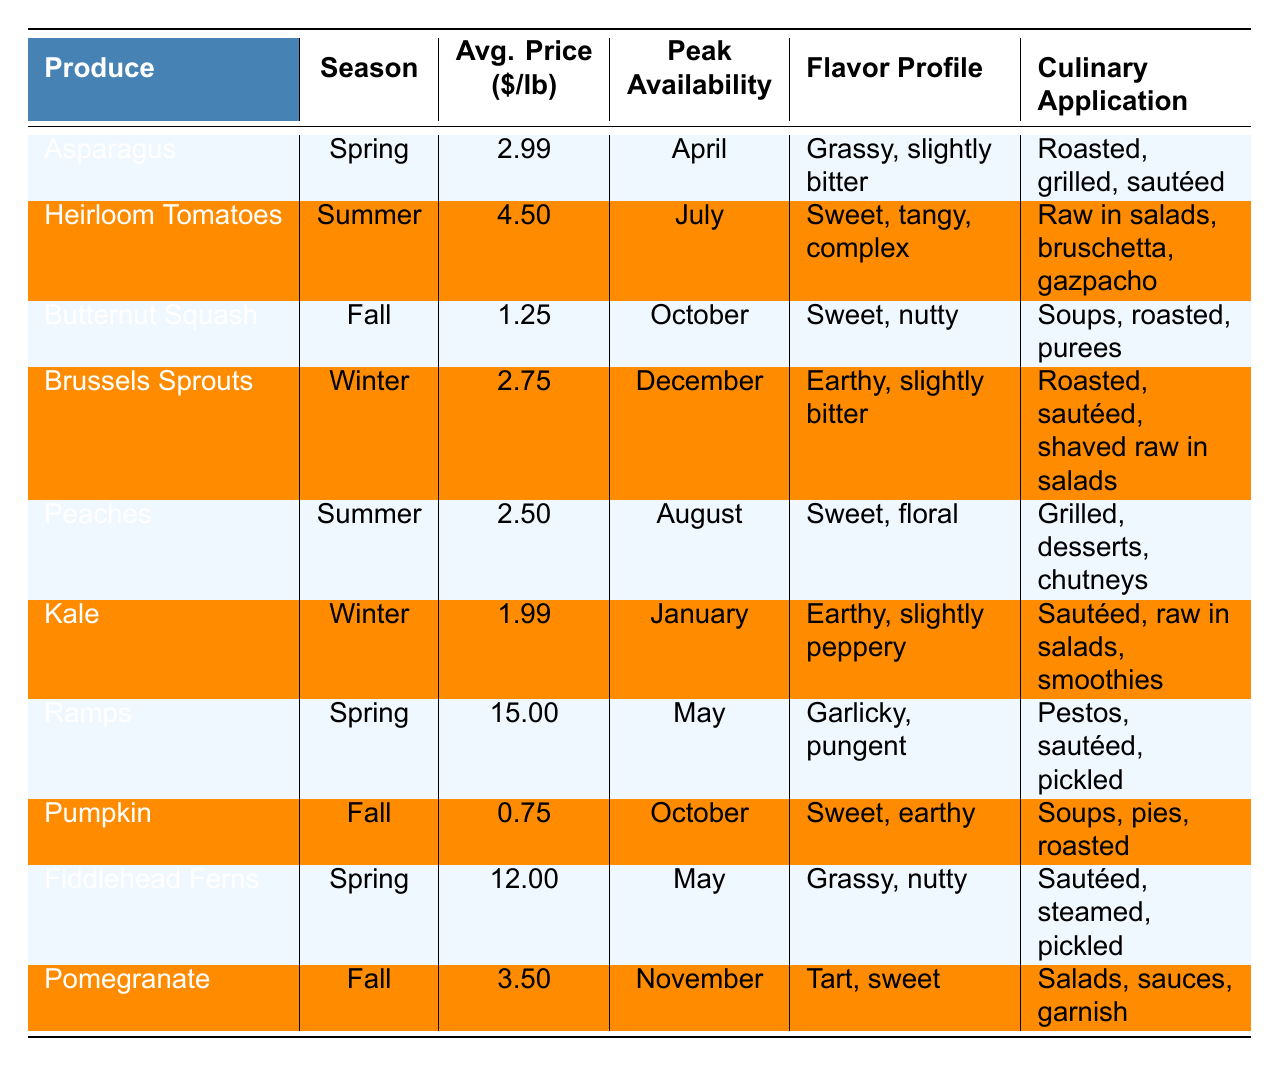What is the average price of asparagus? The table shows the average price of asparagus as $2.99 per pound.
Answer: $2.99 During which season are peaches peak available? The peak availability of peaches is listed as August, which falls in the summer season.
Answer: Summer Is butternut squash more expensive than pomegranate? The average price of butternut squash is $1.25, while pomegranate is $3.50, making butternut squash cheaper.
Answer: No What is the difference in average price between ramps and kale? Ramps are $15.00 per pound and kale is $1.99 per pound. The difference is 15.00 - 1.99 = $13.01.
Answer: $13.01 Which produce has the highest average price? By scanning the table, ramps have the highest average price at $15.00 per pound.
Answer: Ramps How many types of produce are peak available in spring? As per the table, there are three varieties available in spring: asparagus, ramps, and fiddlehead ferns.
Answer: 3 What is the flavor profile of Brussels sprouts? The table describes Brussels sprouts as earthy and slightly bitter.
Answer: Earthy, slightly bitter During which months are butternut squash and pumpkin peak available? Butternut squash is available in October, and pumpkin is also peak available in October. Both share the same peak month.
Answer: October Which produce has the lowest average price, and how much is it? Referring to the table, pumpkin is the lowest at $0.75 per pound.
Answer: Pumpkin, $0.75 What is the total average price of all produce available in the fall season? The average prices for fall produce are: butternut squash ($1.25), pumpkin ($0.75), and pomegranate ($3.50). The total is 1.25 + 0.75 + 3.50 = $5.50.
Answer: $5.50 